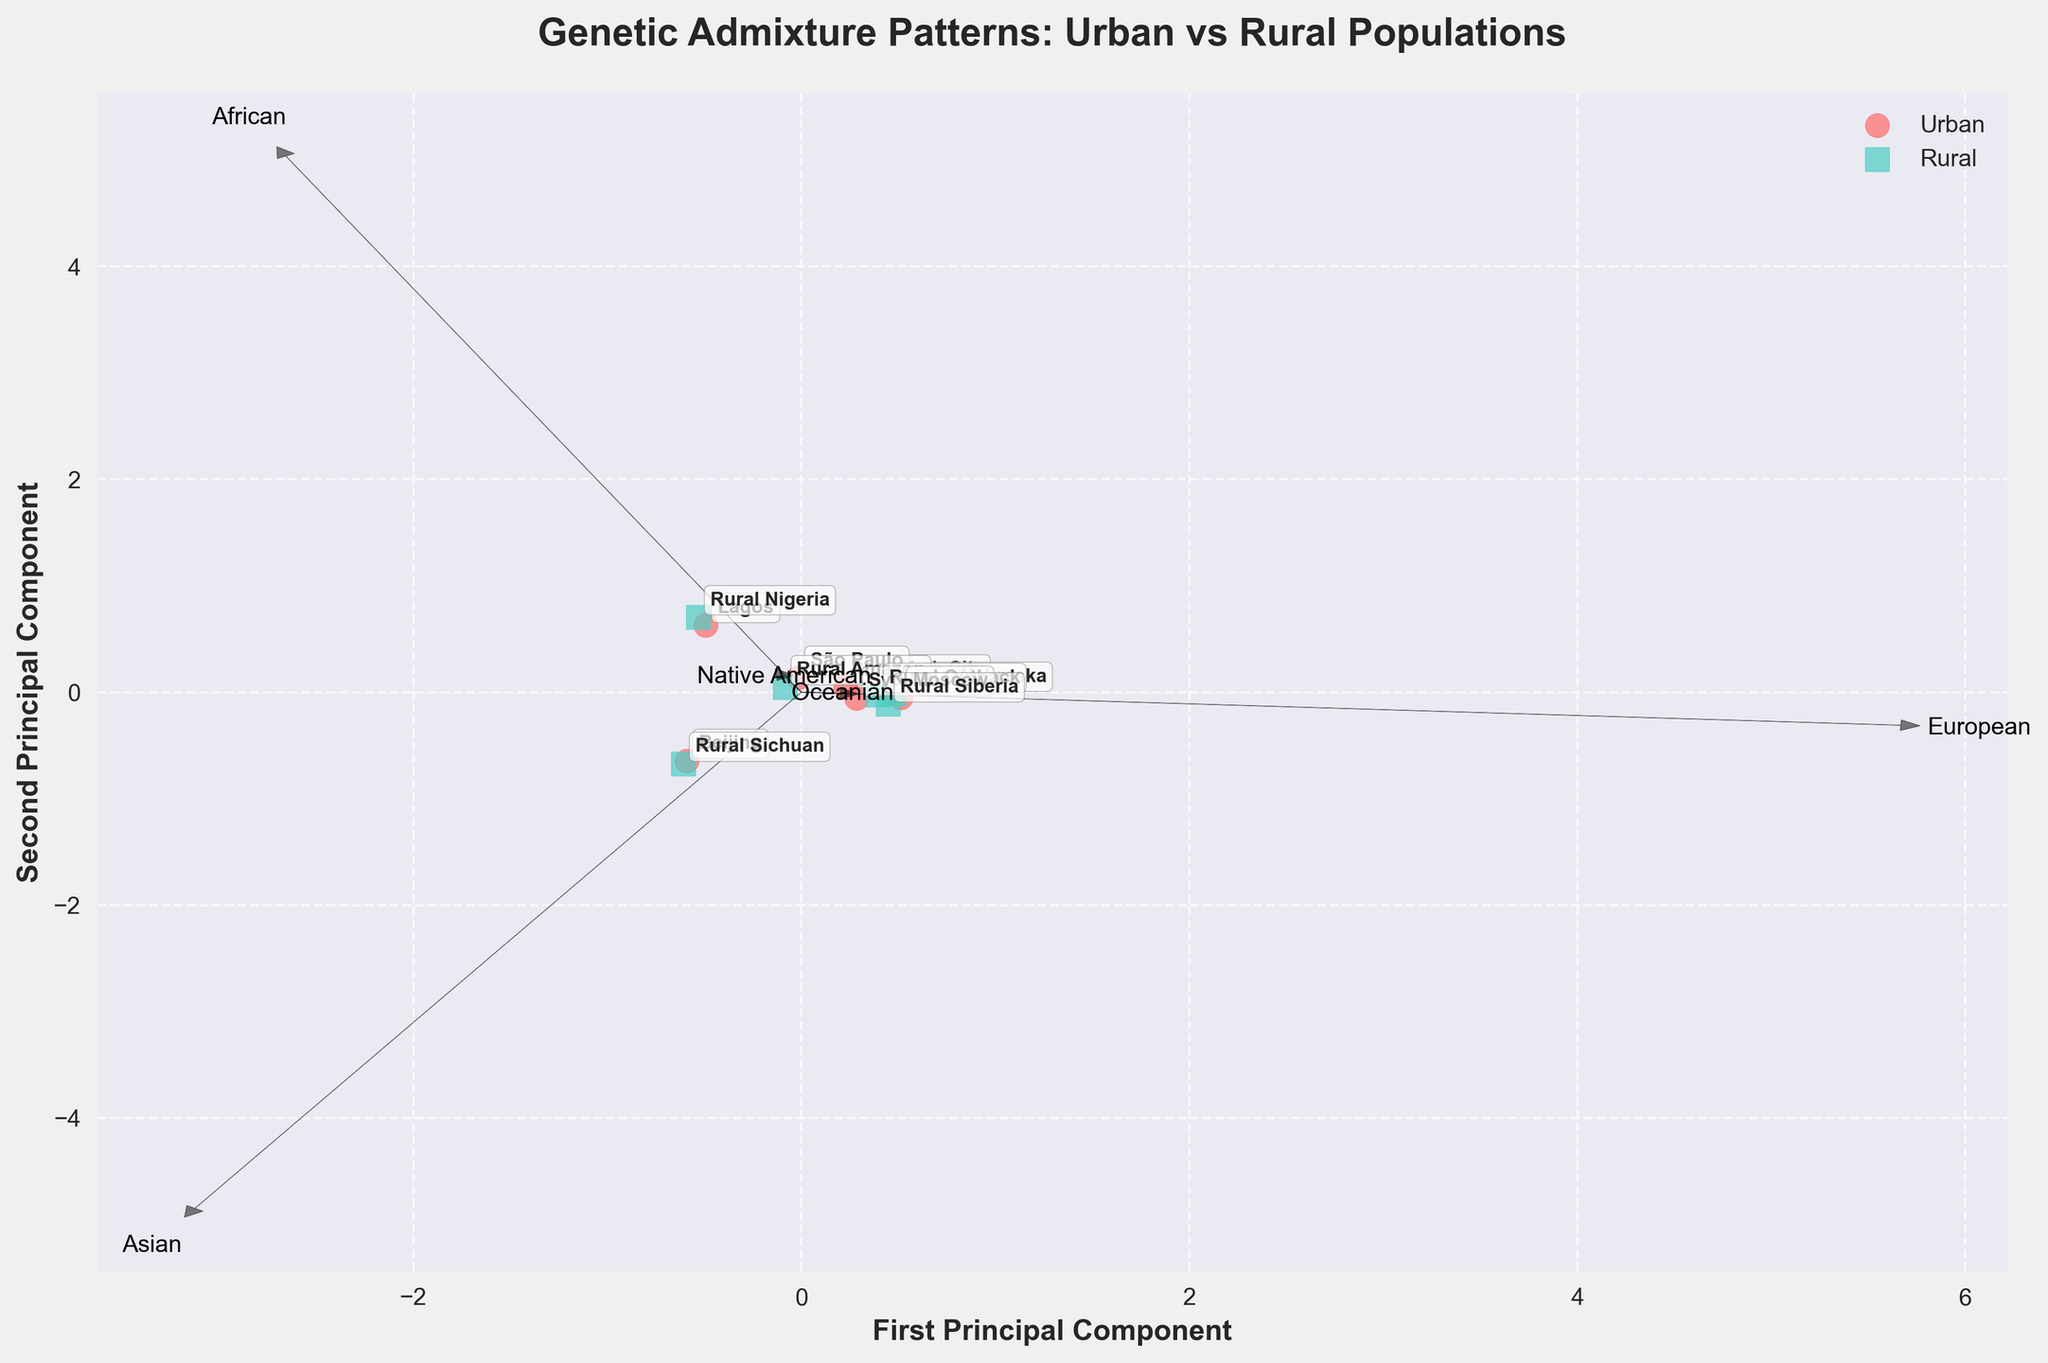What's the title of the figure? The title is usually placed at the top of the figure and it summarizes what the figure is about.
Answer: Genetic Admixture Patterns: Urban vs Rural Populations How many types of populations are compared in the figure? The legend indicates the types of populations being compared.
Answer: Two (Urban and Rural) What does the x-axis represent? The label on the x-axis specifies what it represents.
Answer: First Principal Component Which region is located at the rightmost part of the plot? Look for the label closest to the right edge of the x-axis.
Answer: Moscow What color represents urban populations? The legend indicates the color coding for different populations.
Answer: Red Which rural region has the highest proportion of Native American genetic admixture? Look for regions with 'Rural' tagged and the feature vector labeled "Native American."
Answer: Rural Amazon Are there any populations with a significant admixture from all five genetic groups? Check the spread of urban and rural points around the origin.
Answer: No Which urban population has the most Asian genetic admixture? Look for the urban population plotted closest to the "Asian" vector.
Answer: Beijing Which population has the lowest first principal component score among rural populations? Identify the rural point plotted furthest left along the x-axis.
Answer: Rural Sichuan Which genetic component has the largest influence on the second principal component? Observe the length and direction of the feature vectors plotted from the origin along the y-axis.
Answer: African 